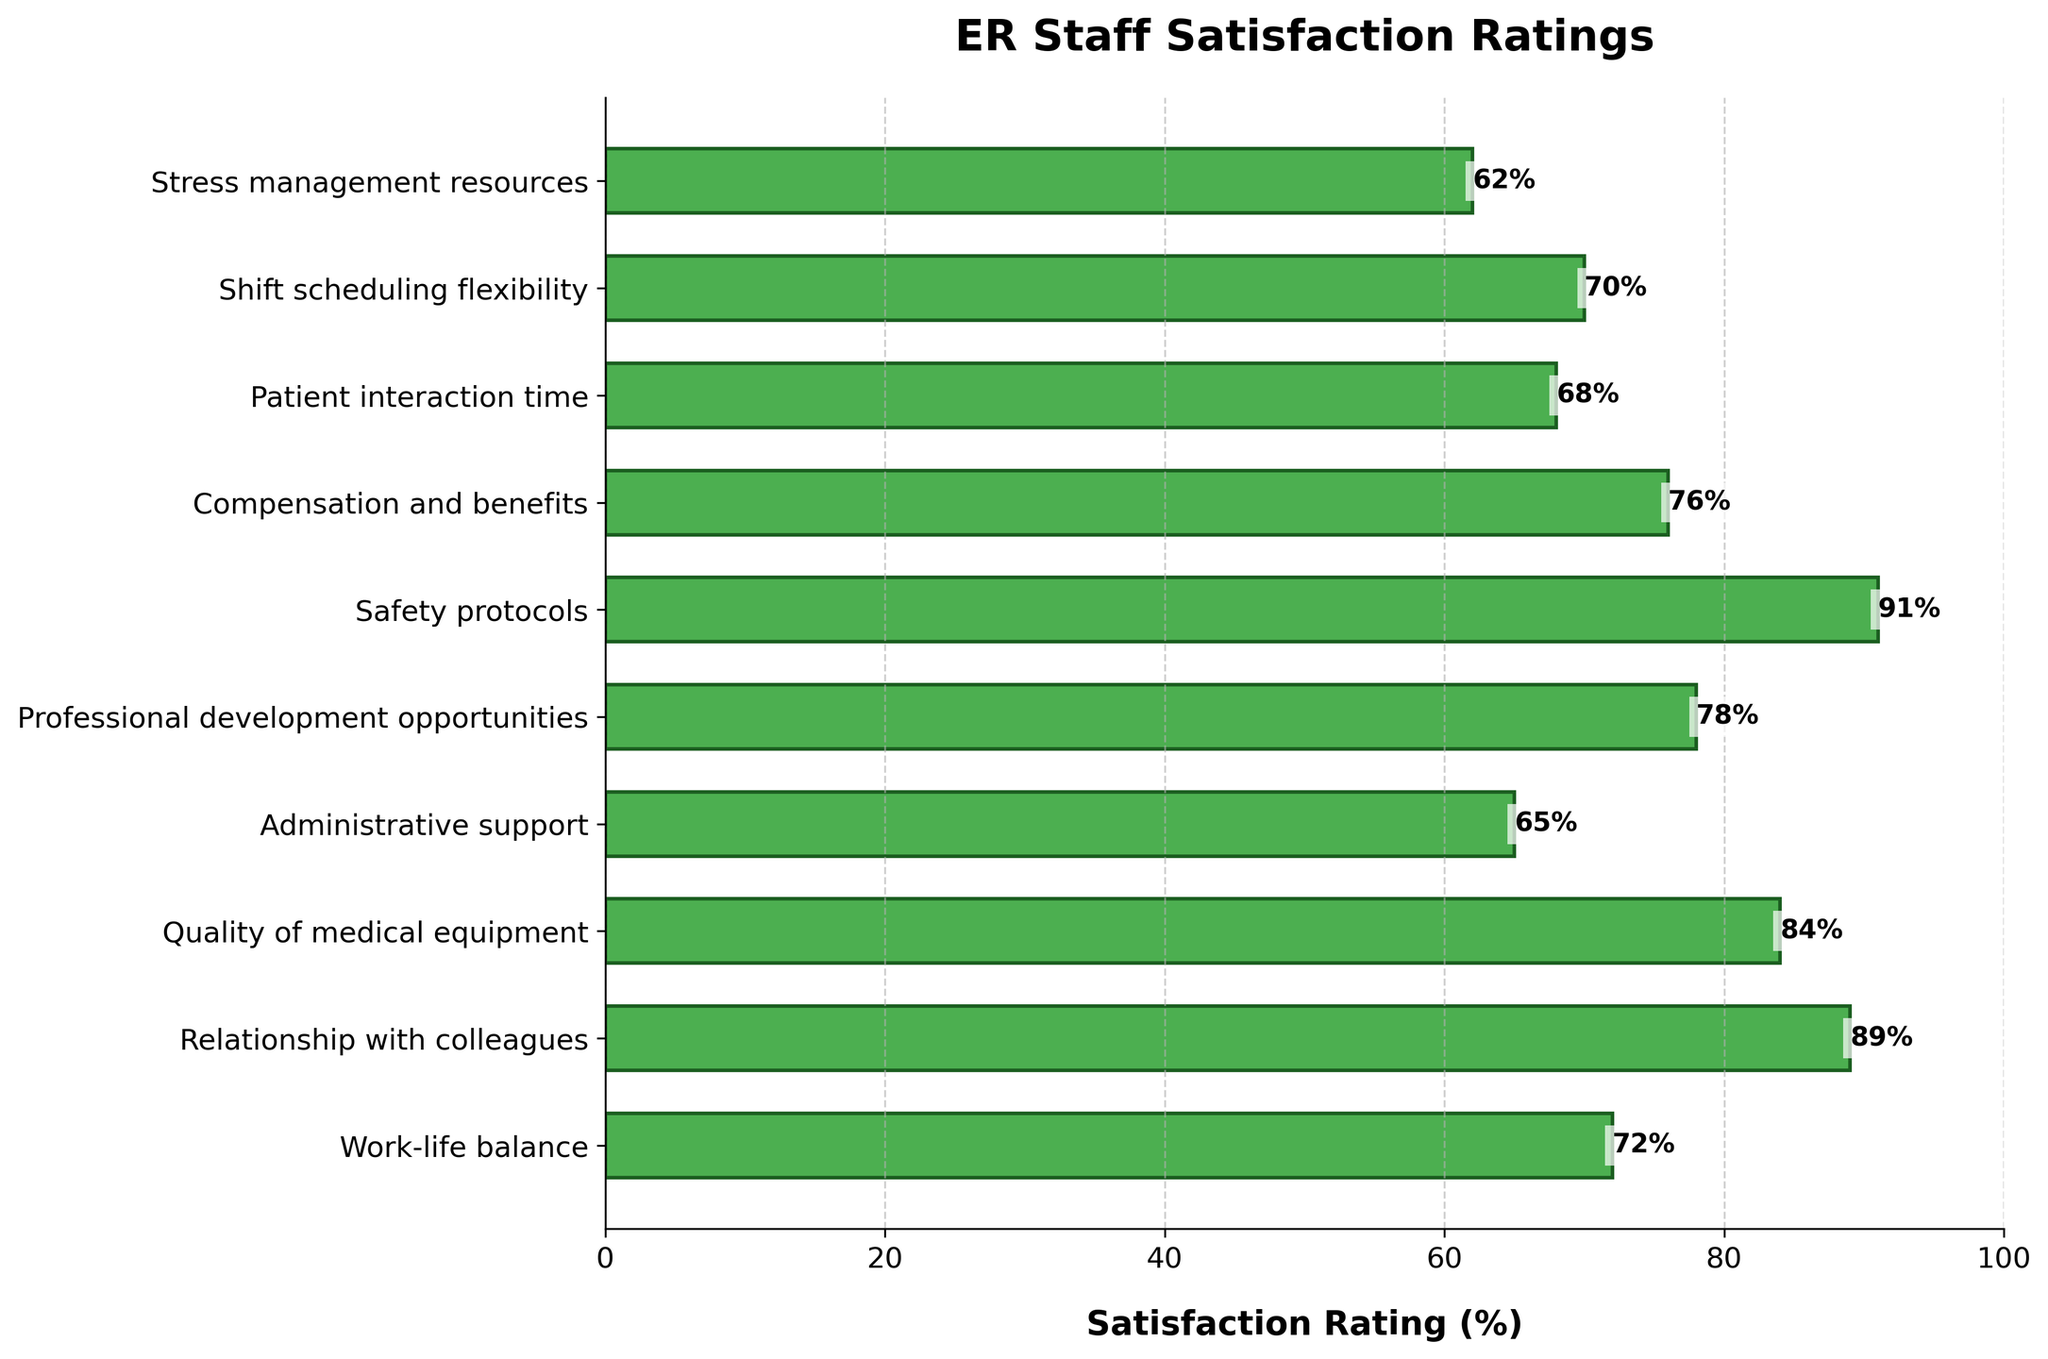Which aspect has the highest satisfaction rating? Observing the bar chart, the aspect with the bar extending furthest to the right indicates the highest satisfaction rating. This is "Safety protocols" with a rating of 91%.
Answer: Safety protocols Which aspect has the lowest satisfaction rating? The aspect with the bar extending the least to the right indicates the lowest satisfaction rating. This is "Stress management resources" with a rating of 62%.
Answer: Stress management resources How much higher is the satisfaction rating for "Relationship with colleagues" compared to "Administrative support"? The satisfaction rating for "Relationship with colleagues" is 89% and for "Administrative support" is 65%. Thus, the difference is 89 - 65 = 24%.
Answer: 24% What is the average satisfaction rating for "Shift scheduling flexibility" and "Work-life balance"? The ratings are 70% for "Shift scheduling flexibility" and 72% for "Work-life balance". The average is (70 + 72) / 2 = 71%.
Answer: 71% Which three aspects have the closest satisfaction ratings? By visually inspecting the bar lengths, "Compensation and benefits" (76%), "Shift scheduling flexibility" (70%), and "Work-life balance" (72%) have ratings close to one another.
Answer: Compensation and benefits, Shift scheduling flexibility, Work-life balance What is the total satisfaction rating for "Professional development opportunities," "Quality of medical equipment," and "Patient interaction time"? The ratings are 78%, 84%, and 68%, respectively. The total is 78 + 84 + 68 = 230%.
Answer: 230% Which aspect holds the median satisfaction rating among all listed aspects? Listing all satisfaction ratings in ascending order: 62, 65, 68, 70, 72, 76, 78, 84, 89, 91. The median value, being the middle value of the ordered list, is the 5th and 6th average: (72 + 76) / 2 = 74%.
Answer: Compensation and benefits Is the satisfaction rating for "Compensation and benefits" higher or lower than "Professional development opportunities"? By how much? The rating for "Compensation and benefits" is 76%, while "Professional development opportunities" is 78%. It is lower by 78 - 76 = 2%.
Answer: Lower by 2% Which aspect's bar appears to be around three-fourths of the chart's maximum rating length? The maximum rating is 100%, and three-fourths of this is 75%. The "Compensation and benefits" rating, at 76%, is very close to this value.
Answer: Compensation and benefits Among the top three aspects with the highest satisfaction ratings, what is their combined percentage? The top three aspects with highest ratings are "Safety protocols" (91%), "Relationship with colleagues" (89%), and "Quality of medical equipment" (84%). Their combined percentage is 91 + 89 + 84 = 264%.
Answer: 264% 